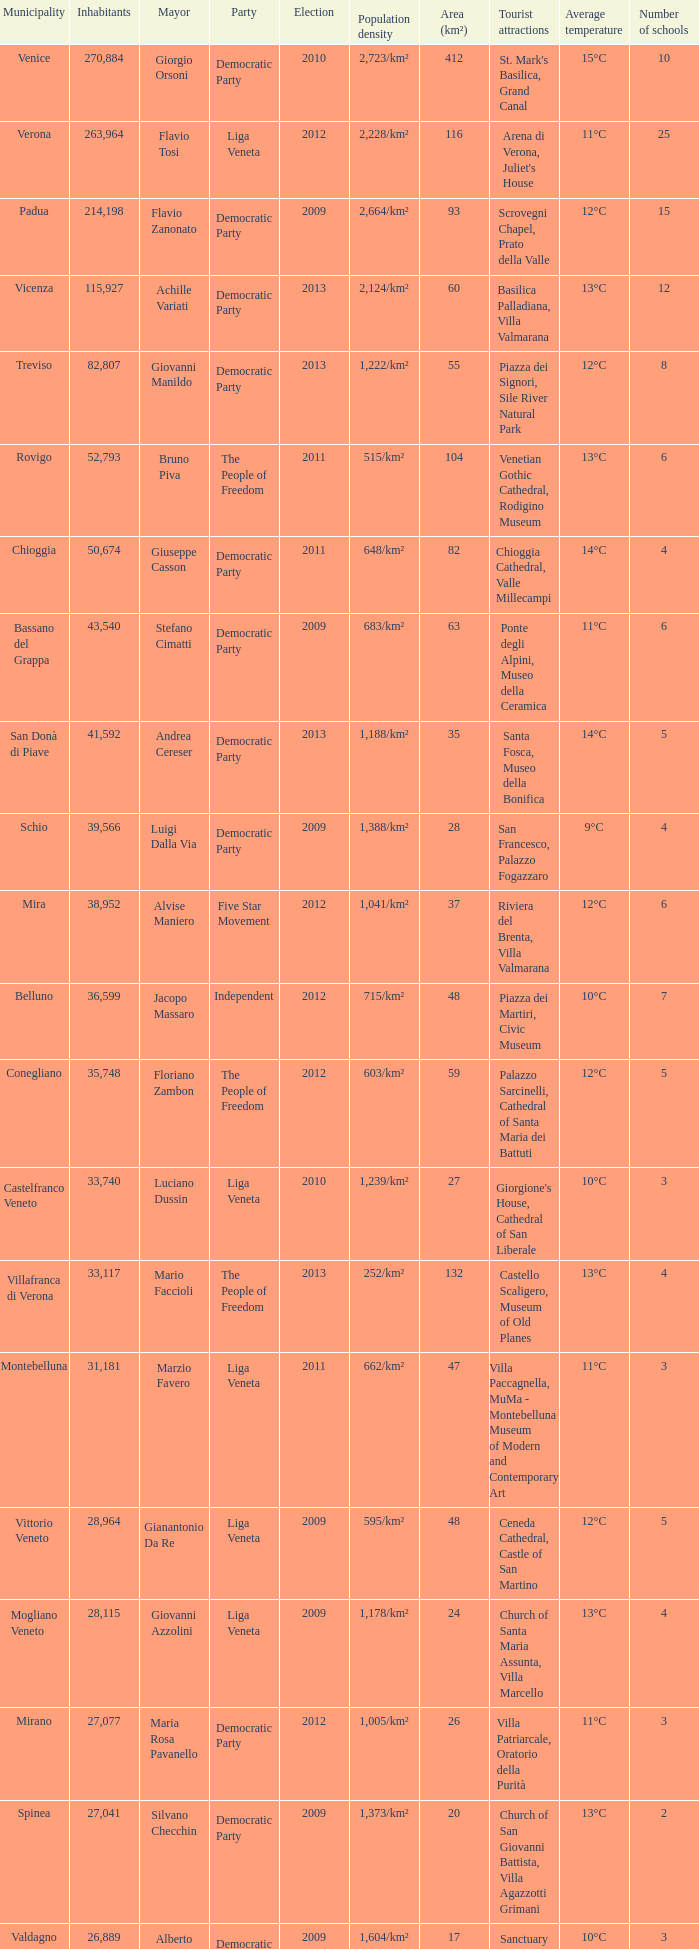How many Inhabitants were in the democratic party for an election before 2009 for Mayor of stefano cimatti? 0.0. 